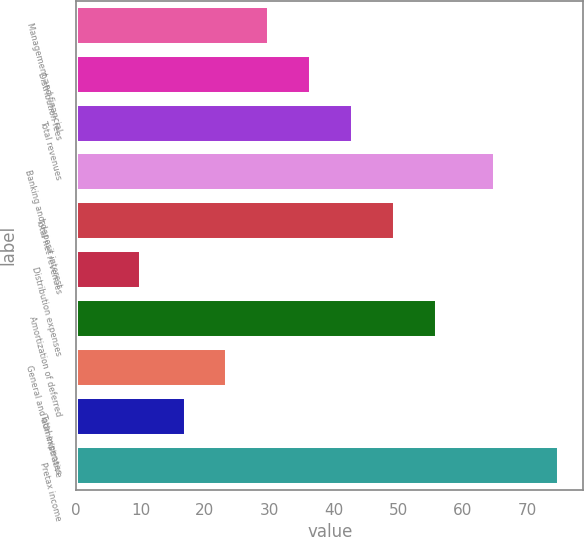<chart> <loc_0><loc_0><loc_500><loc_500><bar_chart><fcel>Management and financial<fcel>Distribution fees<fcel>Total revenues<fcel>Banking and deposit interest<fcel>Total net revenues<fcel>Distribution expenses<fcel>Amortization of deferred<fcel>General and administrative<fcel>Total expenses<fcel>Pretax income<nl><fcel>30<fcel>36.5<fcel>43<fcel>65<fcel>49.5<fcel>10<fcel>56<fcel>23.5<fcel>17<fcel>75<nl></chart> 